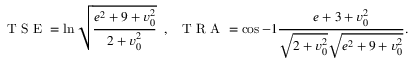Convert formula to latex. <formula><loc_0><loc_0><loc_500><loc_500>T S E = \ln \sqrt { \frac { e ^ { 2 } + 9 + v _ { 0 } ^ { 2 } } { 2 + v _ { 0 } ^ { 2 } } } \, , \, T R A = \cos { - 1 } \frac { e + 3 + v _ { 0 } ^ { 2 } } { \sqrt { 2 + v _ { 0 } ^ { 2 } } \sqrt { e ^ { 2 } + 9 + v _ { 0 } ^ { 2 } } } .</formula> 